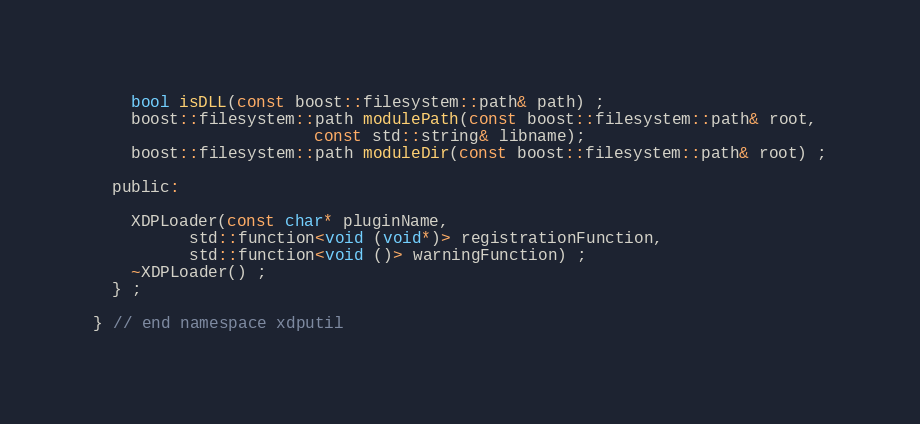Convert code to text. <code><loc_0><loc_0><loc_500><loc_500><_C_>    bool isDLL(const boost::filesystem::path& path) ;
    boost::filesystem::path modulePath(const boost::filesystem::path& root,
				       const std::string& libname);
    boost::filesystem::path moduleDir(const boost::filesystem::path& root) ;
    
  public:

    XDPLoader(const char* pluginName, 
	      std::function<void (void*)> registrationFunction,
	      std::function<void ()> warningFunction) ;
    ~XDPLoader() ;
  } ;
  
} // end namespace xdputil
</code> 